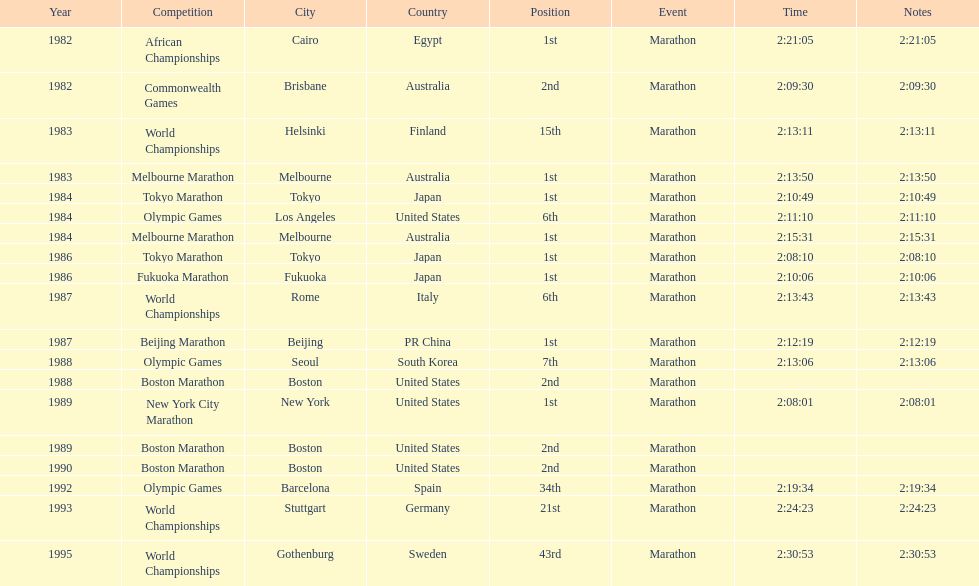In what year did the runner participate in the most marathons? 1984. 